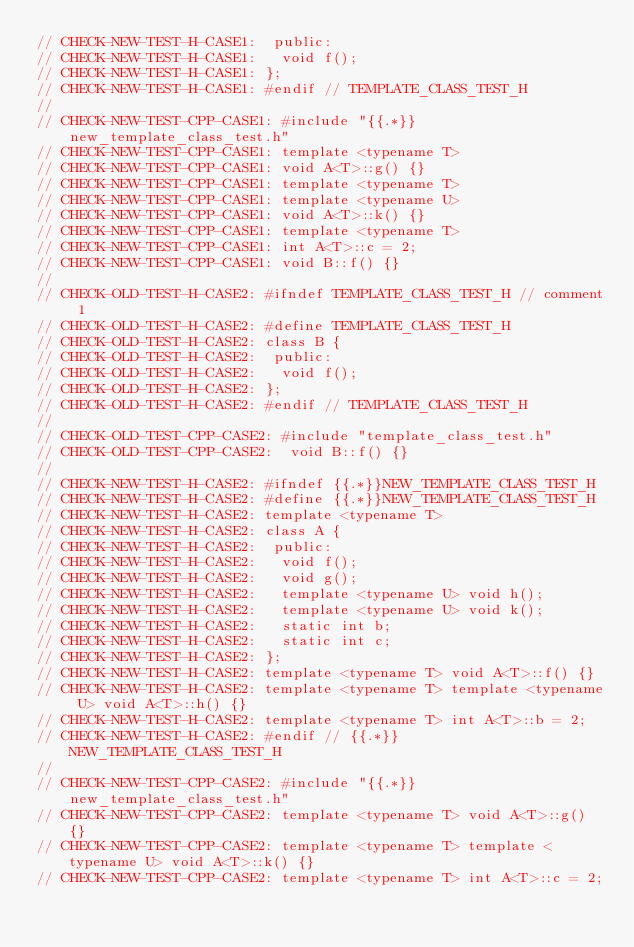Convert code to text. <code><loc_0><loc_0><loc_500><loc_500><_C++_>// CHECK-NEW-TEST-H-CASE1:  public:
// CHECK-NEW-TEST-H-CASE1:   void f();
// CHECK-NEW-TEST-H-CASE1: };
// CHECK-NEW-TEST-H-CASE1: #endif // TEMPLATE_CLASS_TEST_H
//
// CHECK-NEW-TEST-CPP-CASE1: #include "{{.*}}new_template_class_test.h"
// CHECK-NEW-TEST-CPP-CASE1: template <typename T>
// CHECK-NEW-TEST-CPP-CASE1: void A<T>::g() {}
// CHECK-NEW-TEST-CPP-CASE1: template <typename T>
// CHECK-NEW-TEST-CPP-CASE1: template <typename U>
// CHECK-NEW-TEST-CPP-CASE1: void A<T>::k() {}
// CHECK-NEW-TEST-CPP-CASE1: template <typename T>
// CHECK-NEW-TEST-CPP-CASE1: int A<T>::c = 2;
// CHECK-NEW-TEST-CPP-CASE1: void B::f() {}
//
// CHECK-OLD-TEST-H-CASE2: #ifndef TEMPLATE_CLASS_TEST_H // comment 1
// CHECK-OLD-TEST-H-CASE2: #define TEMPLATE_CLASS_TEST_H
// CHECK-OLD-TEST-H-CASE2: class B {
// CHECK-OLD-TEST-H-CASE2:  public:
// CHECK-OLD-TEST-H-CASE2:   void f();
// CHECK-OLD-TEST-H-CASE2: };
// CHECK-OLD-TEST-H-CASE2: #endif // TEMPLATE_CLASS_TEST_H
//
// CHECK-OLD-TEST-CPP-CASE2: #include "template_class_test.h"
// CHECK-OLD-TEST-CPP-CASE2:  void B::f() {}
//
// CHECK-NEW-TEST-H-CASE2: #ifndef {{.*}}NEW_TEMPLATE_CLASS_TEST_H
// CHECK-NEW-TEST-H-CASE2: #define {{.*}}NEW_TEMPLATE_CLASS_TEST_H
// CHECK-NEW-TEST-H-CASE2: template <typename T>
// CHECK-NEW-TEST-H-CASE2: class A {
// CHECK-NEW-TEST-H-CASE2:  public:
// CHECK-NEW-TEST-H-CASE2:   void f();
// CHECK-NEW-TEST-H-CASE2:   void g();
// CHECK-NEW-TEST-H-CASE2:   template <typename U> void h();
// CHECK-NEW-TEST-H-CASE2:   template <typename U> void k();
// CHECK-NEW-TEST-H-CASE2:   static int b;
// CHECK-NEW-TEST-H-CASE2:   static int c;
// CHECK-NEW-TEST-H-CASE2: };
// CHECK-NEW-TEST-H-CASE2: template <typename T> void A<T>::f() {}
// CHECK-NEW-TEST-H-CASE2: template <typename T> template <typename U> void A<T>::h() {}
// CHECK-NEW-TEST-H-CASE2: template <typename T> int A<T>::b = 2;
// CHECK-NEW-TEST-H-CASE2: #endif // {{.*}}NEW_TEMPLATE_CLASS_TEST_H
//
// CHECK-NEW-TEST-CPP-CASE2: #include "{{.*}}new_template_class_test.h"
// CHECK-NEW-TEST-CPP-CASE2: template <typename T> void A<T>::g() {}
// CHECK-NEW-TEST-CPP-CASE2: template <typename T> template <typename U> void A<T>::k() {}
// CHECK-NEW-TEST-CPP-CASE2: template <typename T> int A<T>::c = 2;
</code> 